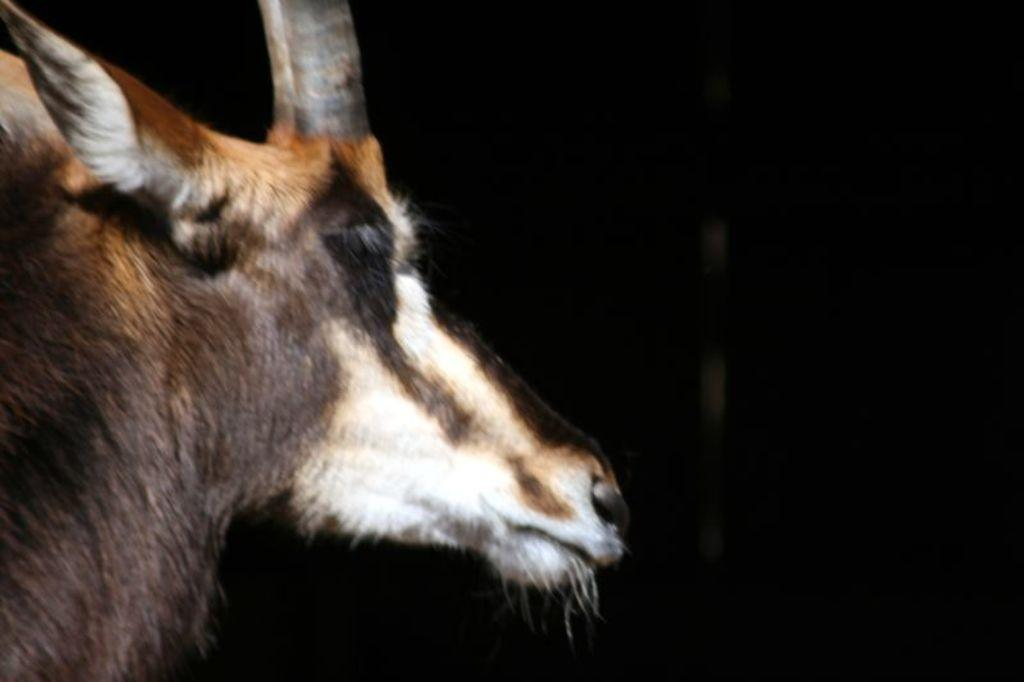What type of animal is in the image? There is an animal in the image, but the specific type cannot be determined from the provided facts. Can you describe the coloring of the animal? The animal has brown and white coloring. What distinguishing feature does the animal have? The animal has a horn. What can be said about the background of the image? The background of the image is completely dark. How many girls are present in the image? There are no girls present in the image; it features an animal with a horn and a dark background. 